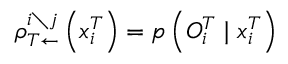Convert formula to latex. <formula><loc_0><loc_0><loc_500><loc_500>\rho _ { T \leftarrow } ^ { i \ j } \left ( x _ { i } ^ { T } \right ) = p \left ( { O } _ { i } ^ { T } | x _ { i } ^ { T } \right )</formula> 